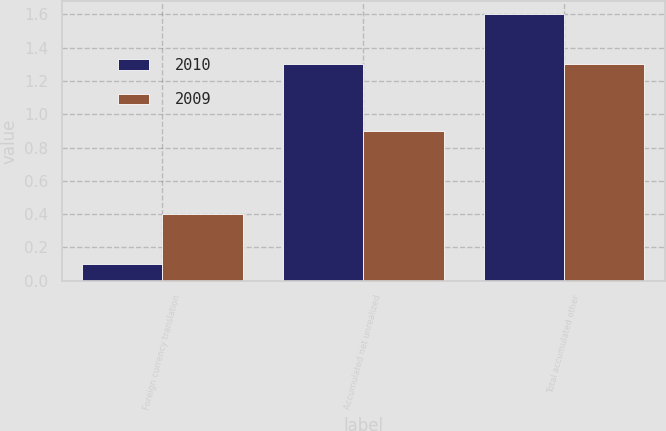Convert chart. <chart><loc_0><loc_0><loc_500><loc_500><stacked_bar_chart><ecel><fcel>Foreign currency translation<fcel>Accumulated net unrealized<fcel>Total accumulated other<nl><fcel>2010<fcel>0.1<fcel>1.3<fcel>1.6<nl><fcel>2009<fcel>0.4<fcel>0.9<fcel>1.3<nl></chart> 